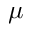Convert formula to latex. <formula><loc_0><loc_0><loc_500><loc_500>\mu</formula> 